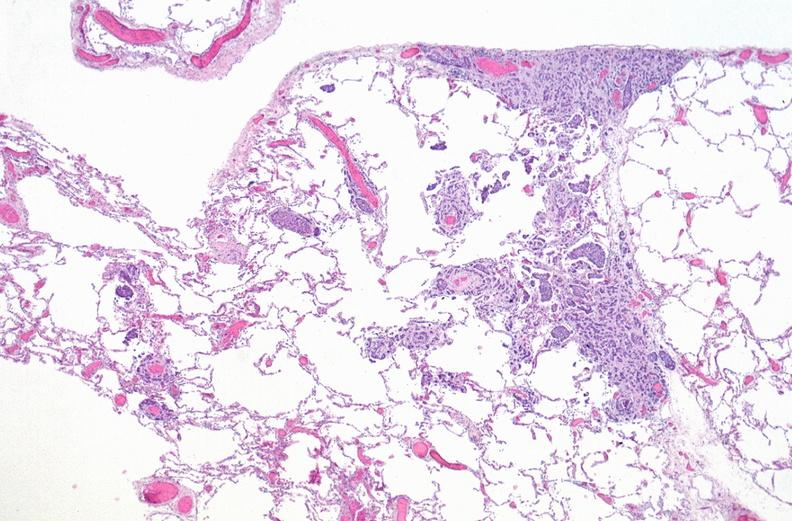does this image show breast cancer metastasis to lung?
Answer the question using a single word or phrase. Yes 